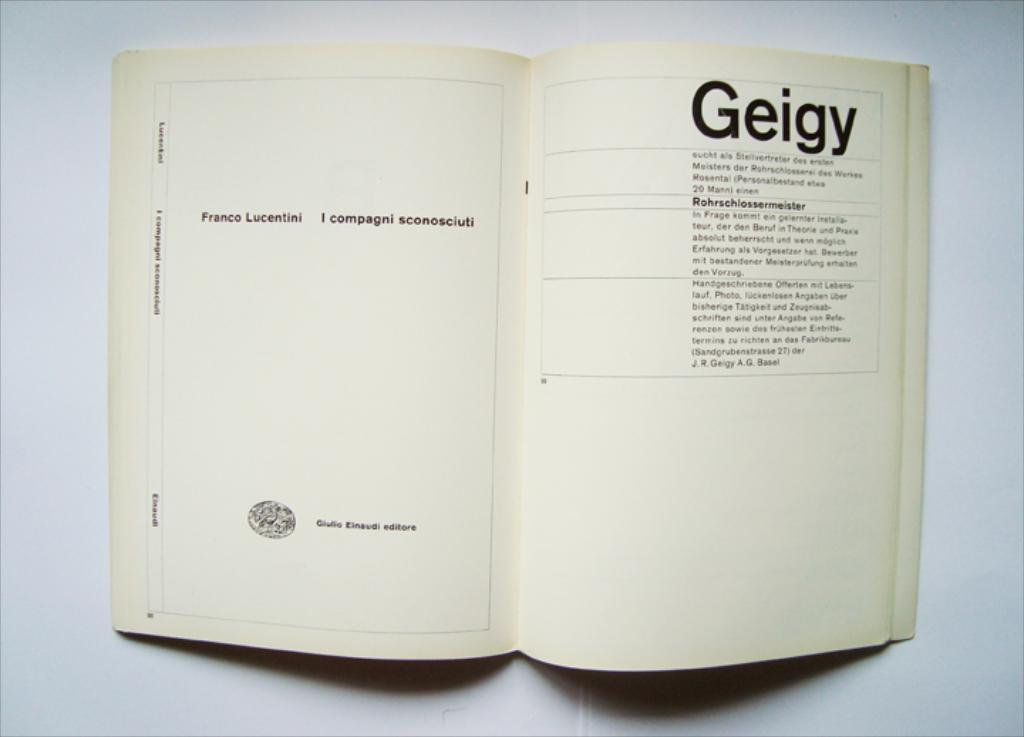Provide a one-sentence caption for the provided image. Book with the word Geigy and the meaning for the word. 